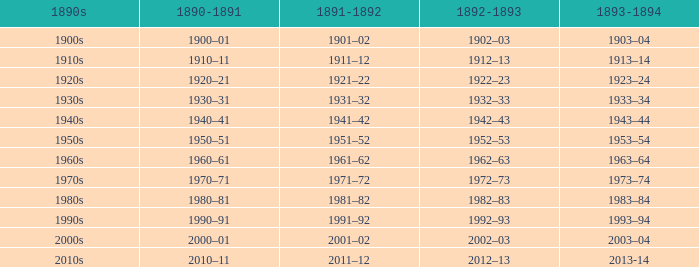What years from 1893-94 that is from the 1890s to the 1990s? 1993–94. 